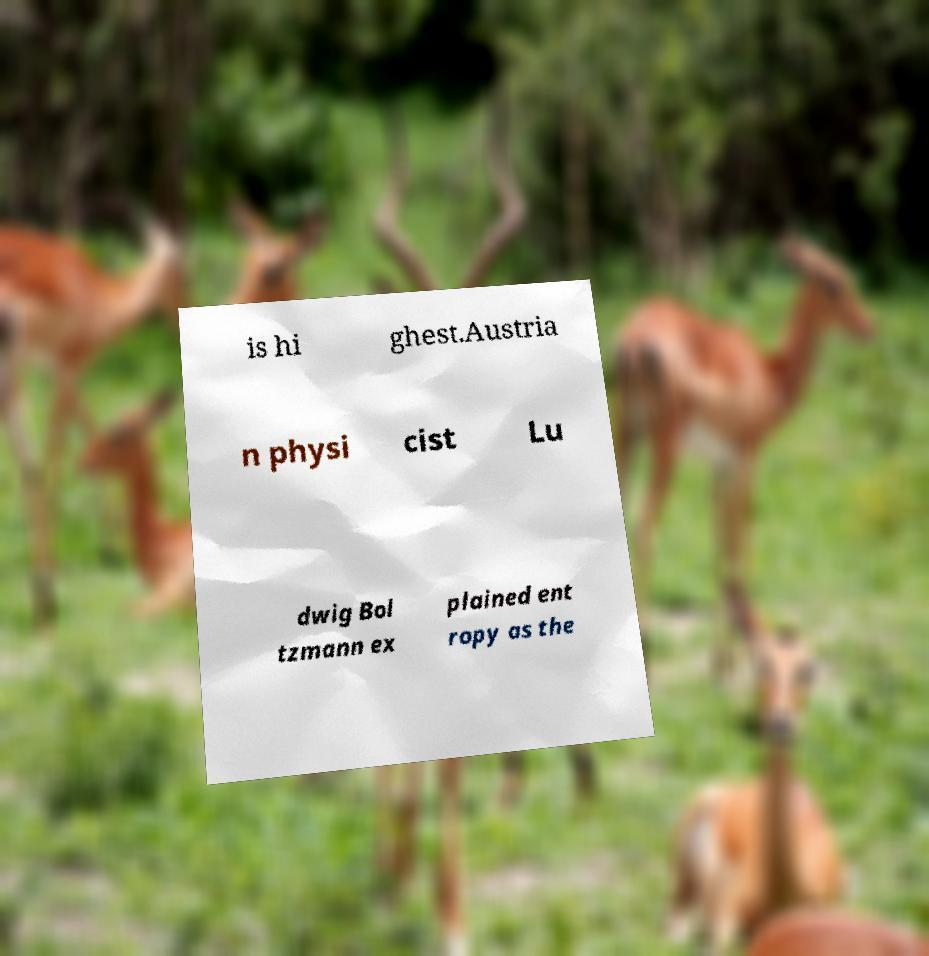I need the written content from this picture converted into text. Can you do that? is hi ghest.Austria n physi cist Lu dwig Bol tzmann ex plained ent ropy as the 